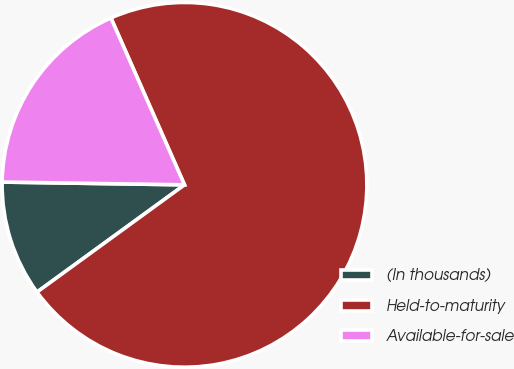Convert chart. <chart><loc_0><loc_0><loc_500><loc_500><pie_chart><fcel>(In thousands)<fcel>Held-to-maturity<fcel>Available-for-sale<nl><fcel>10.25%<fcel>71.6%<fcel>18.15%<nl></chart> 